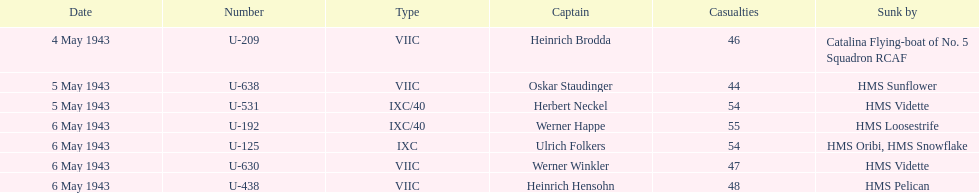Aside from oskar staudinger what was the name of the other captain of the u-boat loast on may 5? Herbert Neckel. 